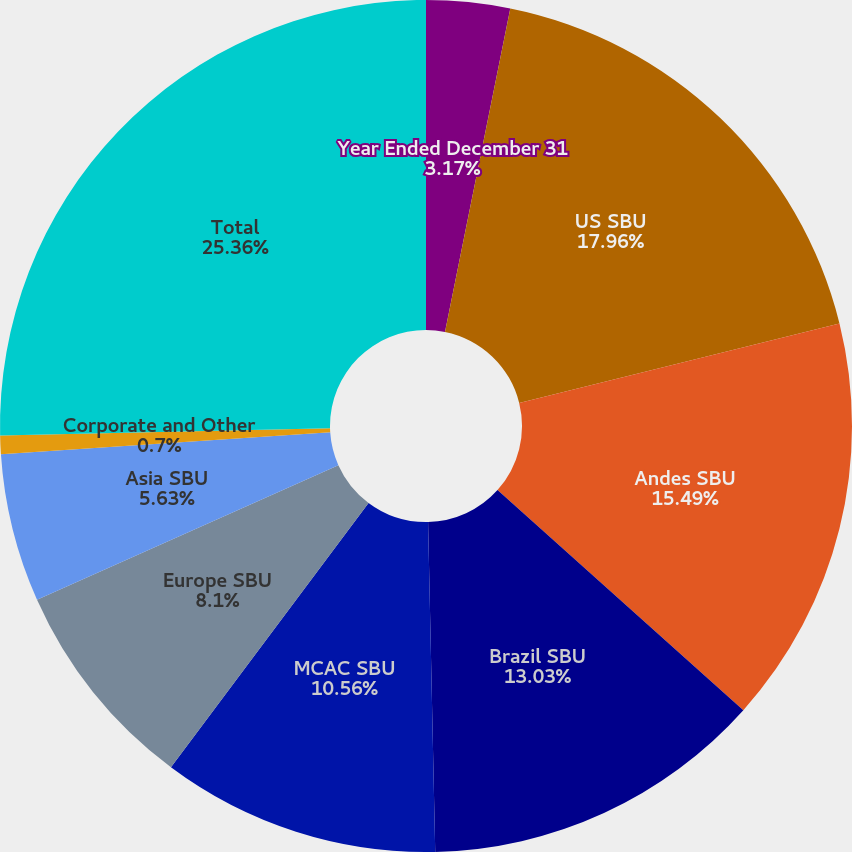Convert chart to OTSL. <chart><loc_0><loc_0><loc_500><loc_500><pie_chart><fcel>Year Ended December 31<fcel>US SBU<fcel>Andes SBU<fcel>Brazil SBU<fcel>MCAC SBU<fcel>Europe SBU<fcel>Asia SBU<fcel>Corporate and Other<fcel>Total<nl><fcel>3.17%<fcel>17.96%<fcel>15.49%<fcel>13.03%<fcel>10.56%<fcel>8.1%<fcel>5.63%<fcel>0.7%<fcel>25.35%<nl></chart> 